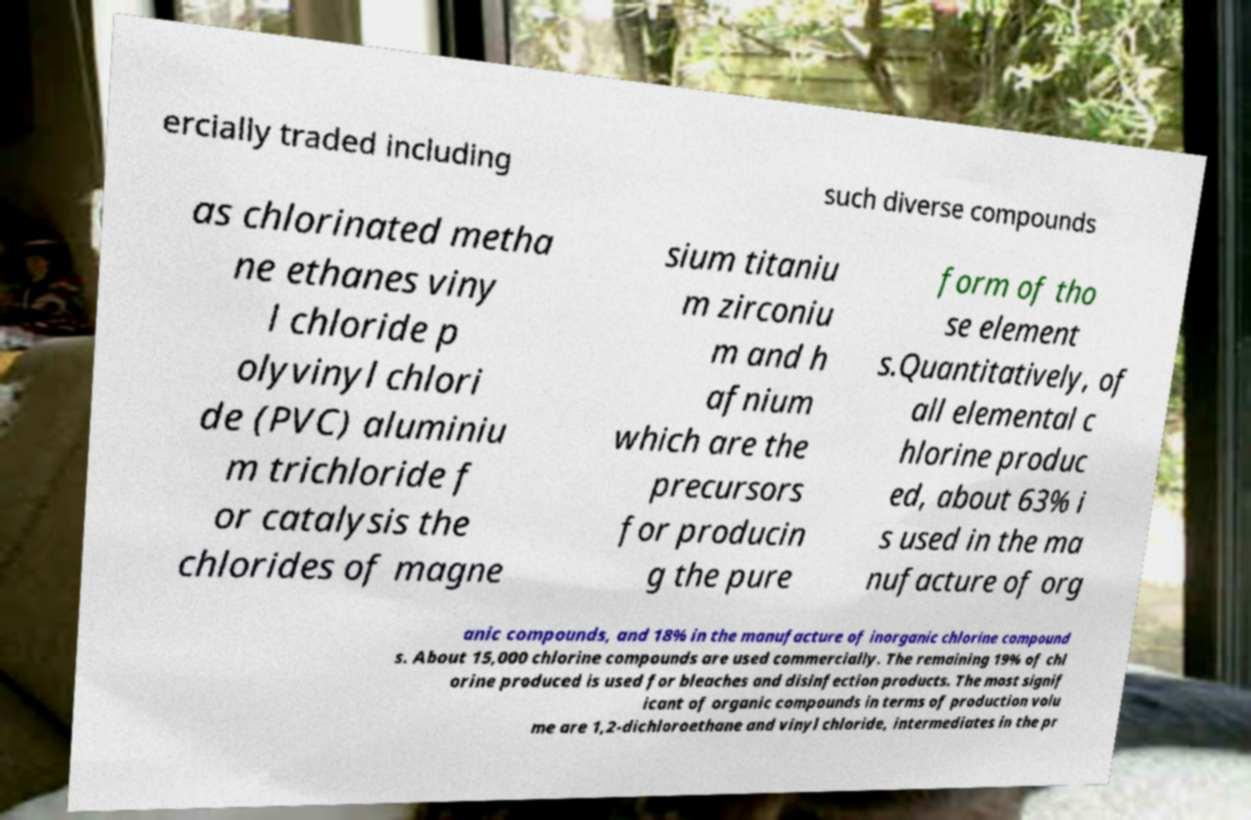What messages or text are displayed in this image? I need them in a readable, typed format. ercially traded including such diverse compounds as chlorinated metha ne ethanes viny l chloride p olyvinyl chlori de (PVC) aluminiu m trichloride f or catalysis the chlorides of magne sium titaniu m zirconiu m and h afnium which are the precursors for producin g the pure form of tho se element s.Quantitatively, of all elemental c hlorine produc ed, about 63% i s used in the ma nufacture of org anic compounds, and 18% in the manufacture of inorganic chlorine compound s. About 15,000 chlorine compounds are used commercially. The remaining 19% of chl orine produced is used for bleaches and disinfection products. The most signif icant of organic compounds in terms of production volu me are 1,2-dichloroethane and vinyl chloride, intermediates in the pr 